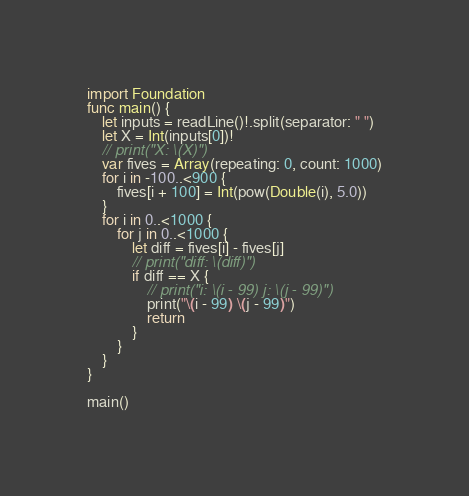<code> <loc_0><loc_0><loc_500><loc_500><_Swift_>import Foundation
func main() {
    let inputs = readLine()!.split(separator: " ")
    let X = Int(inputs[0])!
    // print("X: \(X)")
    var fives = Array(repeating: 0, count: 1000)
    for i in -100..<900 {
        fives[i + 100] = Int(pow(Double(i), 5.0))
    }
    for i in 0..<1000 {
        for j in 0..<1000 {
            let diff = fives[i] - fives[j]
            // print("diff: \(diff)")
            if diff == X {
                // print("i: \(i - 99) j: \(j - 99)")
                print("\(i - 99) \(j - 99)")
                return
            }
        }
    }
}

main()</code> 